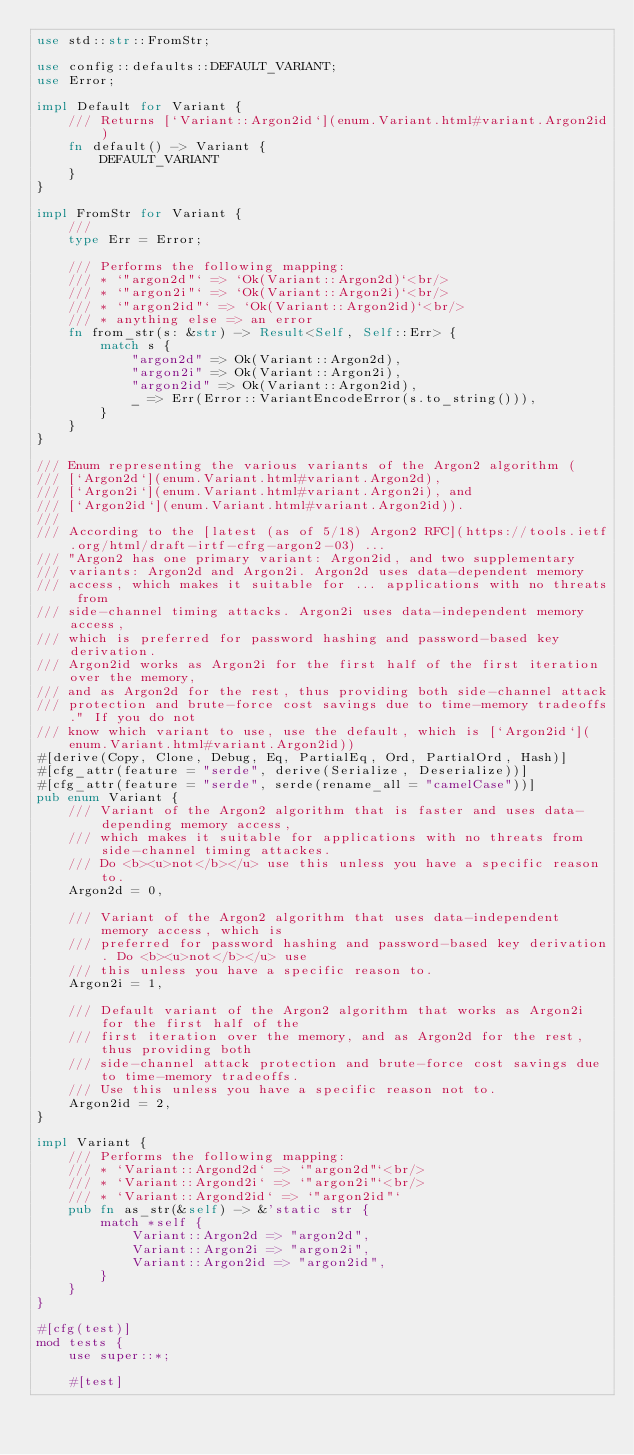<code> <loc_0><loc_0><loc_500><loc_500><_Rust_>use std::str::FromStr;

use config::defaults::DEFAULT_VARIANT;
use Error;

impl Default for Variant {
    /// Returns [`Variant::Argon2id`](enum.Variant.html#variant.Argon2id)
    fn default() -> Variant {
        DEFAULT_VARIANT
    }
}

impl FromStr for Variant {
    ///
    type Err = Error;

    /// Performs the following mapping:
    /// * `"argon2d"` => `Ok(Variant::Argon2d)`<br/>
    /// * `"argon2i"` => `Ok(Variant::Argon2i)`<br/>
    /// * `"argon2id"` => `Ok(Variant::Argon2id)`<br/>
    /// * anything else => an error
    fn from_str(s: &str) -> Result<Self, Self::Err> {
        match s {
            "argon2d" => Ok(Variant::Argon2d),
            "argon2i" => Ok(Variant::Argon2i),
            "argon2id" => Ok(Variant::Argon2id),
            _ => Err(Error::VariantEncodeError(s.to_string())),
        }
    }
}

/// Enum representing the various variants of the Argon2 algorithm (
/// [`Argon2d`](enum.Variant.html#variant.Argon2d),
/// [`Argon2i`](enum.Variant.html#variant.Argon2i), and
/// [`Argon2id`](enum.Variant.html#variant.Argon2id)).
///
/// According to the [latest (as of 5/18) Argon2 RFC](https://tools.ietf.org/html/draft-irtf-cfrg-argon2-03) ...
/// "Argon2 has one primary variant: Argon2id, and two supplementary
/// variants: Argon2d and Argon2i. Argon2d uses data-dependent memory
/// access, which makes it suitable for ... applications with no threats from
/// side-channel timing attacks. Argon2i uses data-independent memory access,
/// which is preferred for password hashing and password-based key derivation.
/// Argon2id works as Argon2i for the first half of the first iteration over the memory,
/// and as Argon2d for the rest, thus providing both side-channel attack
/// protection and brute-force cost savings due to time-memory tradeoffs." If you do not
/// know which variant to use, use the default, which is [`Argon2id`](enum.Variant.html#variant.Argon2id))
#[derive(Copy, Clone, Debug, Eq, PartialEq, Ord, PartialOrd, Hash)]
#[cfg_attr(feature = "serde", derive(Serialize, Deserialize))]
#[cfg_attr(feature = "serde", serde(rename_all = "camelCase"))]
pub enum Variant {
    /// Variant of the Argon2 algorithm that is faster and uses data-depending memory access,
    /// which makes it suitable for applications with no threats from side-channel timing attackes.
    /// Do <b><u>not</b></u> use this unless you have a specific reason to.
    Argon2d = 0,

    /// Variant of the Argon2 algorithm that uses data-independent memory access, which is
    /// preferred for password hashing and password-based key derivation. Do <b><u>not</b></u> use
    /// this unless you have a specific reason to.
    Argon2i = 1,

    /// Default variant of the Argon2 algorithm that works as Argon2i for the first half of the
    /// first iteration over the memory, and as Argon2d for the rest, thus providing both
    /// side-channel attack protection and brute-force cost savings due to time-memory tradeoffs.
    /// Use this unless you have a specific reason not to.
    Argon2id = 2,
}

impl Variant {
    /// Performs the following mapping:
    /// * `Variant::Argond2d` => `"argon2d"`<br/>
    /// * `Variant::Argond2i` => `"argon2i"`<br/>
    /// * `Variant::Argond2id` => `"argon2id"`
    pub fn as_str(&self) -> &'static str {
        match *self {
            Variant::Argon2d => "argon2d",
            Variant::Argon2i => "argon2i",
            Variant::Argon2id => "argon2id",
        }
    }
}

#[cfg(test)]
mod tests {
    use super::*;

    #[test]</code> 